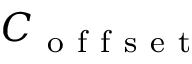<formula> <loc_0><loc_0><loc_500><loc_500>C _ { o f f s e t }</formula> 